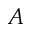<formula> <loc_0><loc_0><loc_500><loc_500>A</formula> 